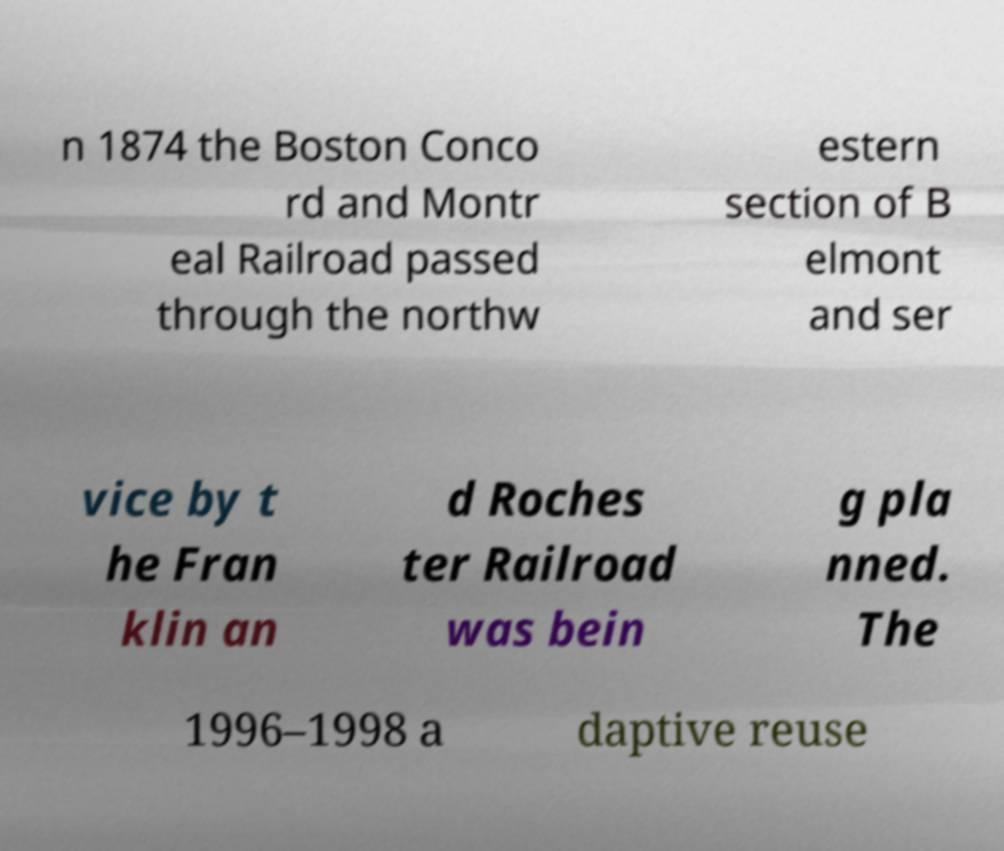For documentation purposes, I need the text within this image transcribed. Could you provide that? n 1874 the Boston Conco rd and Montr eal Railroad passed through the northw estern section of B elmont and ser vice by t he Fran klin an d Roches ter Railroad was bein g pla nned. The 1996–1998 a daptive reuse 